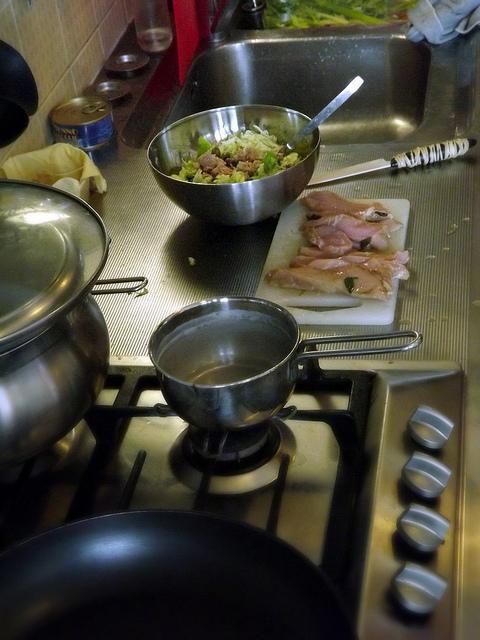How many knobs are on the stove?
Give a very brief answer. 4. How many people are wearing black pants?
Give a very brief answer. 0. 